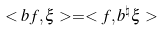Convert formula to latex. <formula><loc_0><loc_0><loc_500><loc_500>< b f , \xi > = < f , b ^ { \natural } \xi ></formula> 